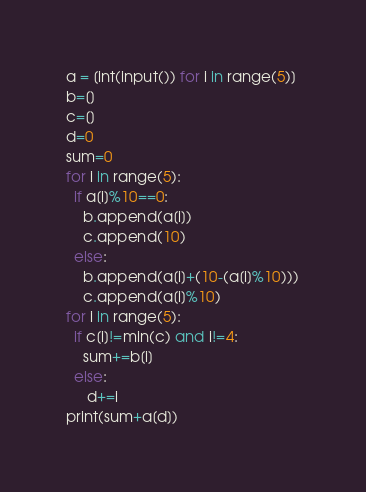Convert code to text. <code><loc_0><loc_0><loc_500><loc_500><_Python_>a = [int(input()) for i in range(5)] 
b=[]
c=[]
d=0
sum=0
for i in range(5):
  if a[i]%10==0:
    b.append(a[i])
    c.append(10) 
  else:
    b.append(a[i]+(10-(a[i]%10)))
    c.append(a[i]%10) 
for i in range(5):
  if c[i]!=min(c) and i!=4:
    sum+=b[i]
  else:
     d+=i
print(sum+a[d])</code> 